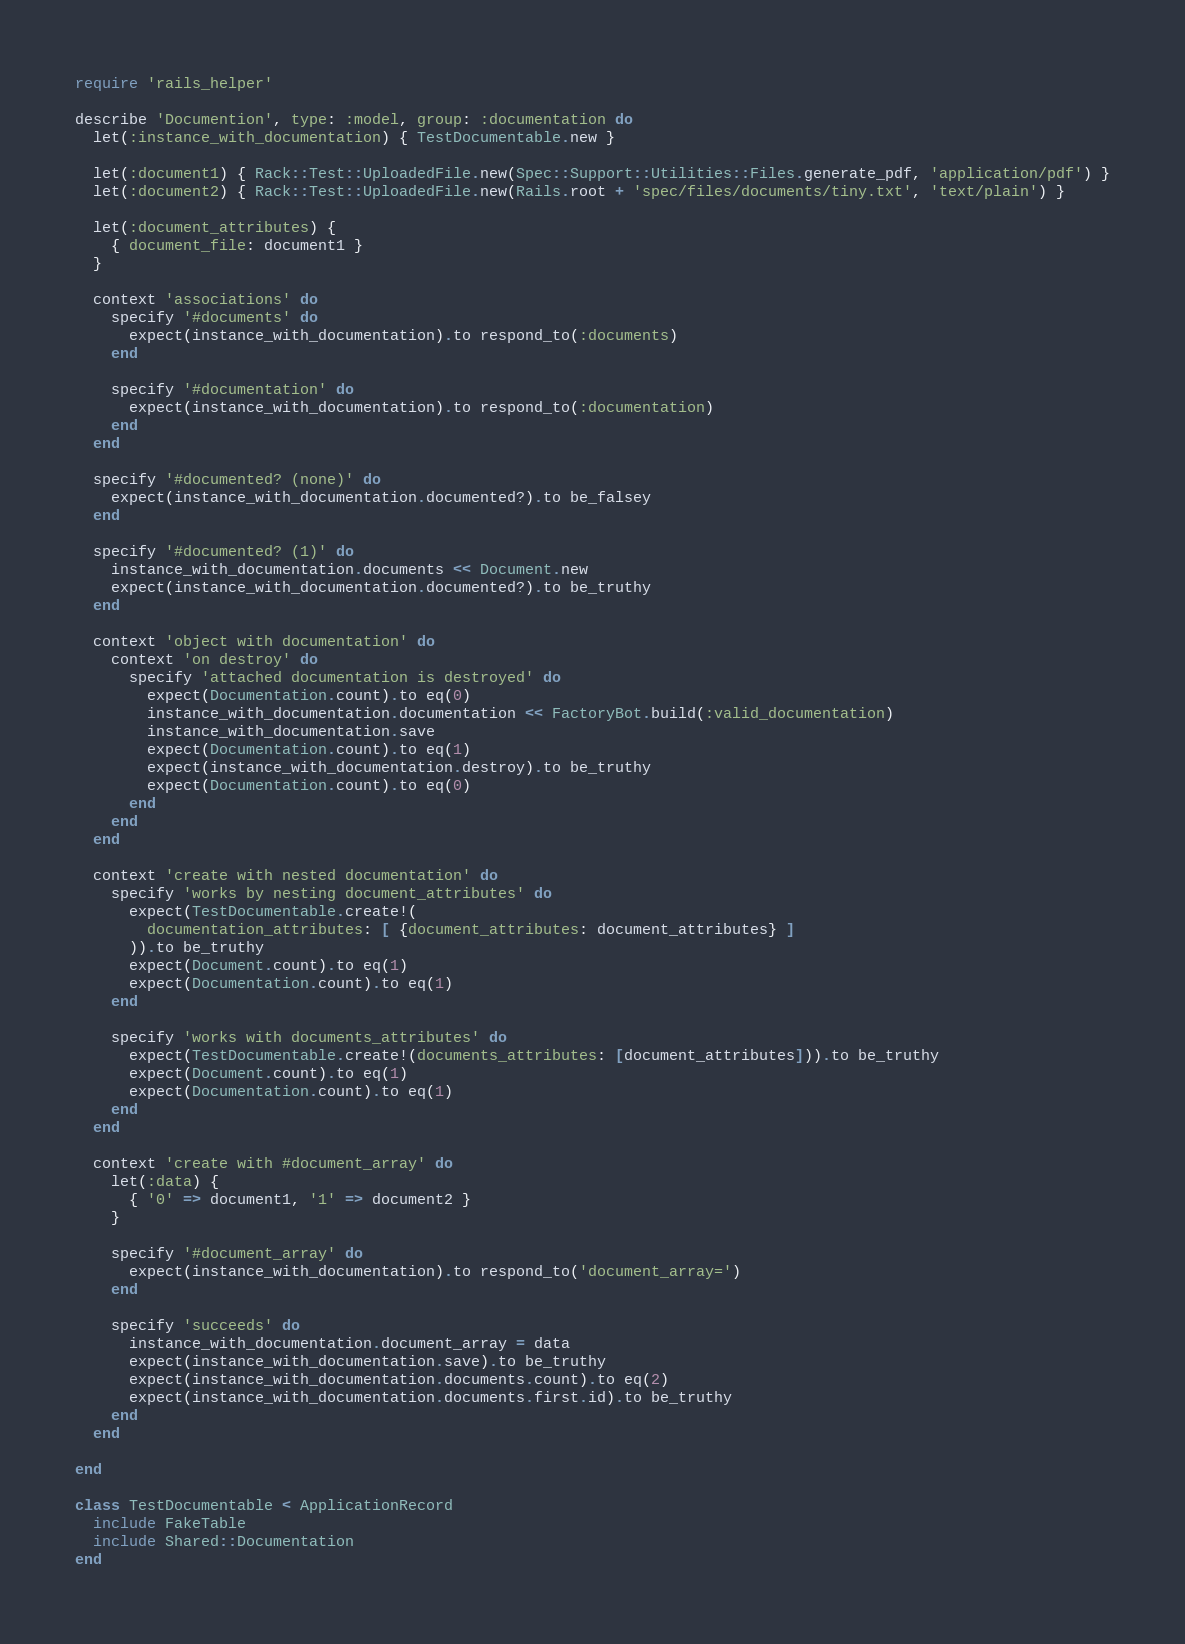<code> <loc_0><loc_0><loc_500><loc_500><_Ruby_>require 'rails_helper'

describe 'Documention', type: :model, group: :documentation do
  let(:instance_with_documentation) { TestDocumentable.new }

  let(:document1) { Rack::Test::UploadedFile.new(Spec::Support::Utilities::Files.generate_pdf, 'application/pdf') }
  let(:document2) { Rack::Test::UploadedFile.new(Rails.root + 'spec/files/documents/tiny.txt', 'text/plain') }

  let(:document_attributes) {
    { document_file: document1 }
  }

  context 'associations' do
    specify '#documents' do
      expect(instance_with_documentation).to respond_to(:documents)
    end

    specify '#documentation' do 
      expect(instance_with_documentation).to respond_to(:documentation)
    end
  end

  specify '#documented? (none)' do
    expect(instance_with_documentation.documented?).to be_falsey 
  end

  specify '#documented? (1)' do
    instance_with_documentation.documents << Document.new
    expect(instance_with_documentation.documented?).to be_truthy
  end

  context 'object with documentation' do
    context 'on destroy' do
      specify 'attached documentation is destroyed' do
        expect(Documentation.count).to eq(0)
        instance_with_documentation.documentation << FactoryBot.build(:valid_documentation)
        instance_with_documentation.save
        expect(Documentation.count).to eq(1)
        expect(instance_with_documentation.destroy).to be_truthy
        expect(Documentation.count).to eq(0)
      end
    end
  end

  context 'create with nested documentation' do
    specify 'works by nesting document_attributes' do
      expect(TestDocumentable.create!(
        documentation_attributes: [ {document_attributes: document_attributes} ]
      )).to be_truthy
      expect(Document.count).to eq(1)
      expect(Documentation.count).to eq(1)
    end

    specify 'works with documents_attributes' do
      expect(TestDocumentable.create!(documents_attributes: [document_attributes])).to be_truthy
      expect(Document.count).to eq(1)
      expect(Documentation.count).to eq(1)
    end
  end

  context 'create with #document_array' do
    let(:data) {
      { '0' => document1, '1' => document2 }
    }

    specify '#document_array' do
      expect(instance_with_documentation).to respond_to('document_array=')
    end

    specify 'succeeds' do
      instance_with_documentation.document_array = data
      expect(instance_with_documentation.save).to be_truthy
      expect(instance_with_documentation.documents.count).to eq(2)
      expect(instance_with_documentation.documents.first.id).to be_truthy
    end
  end

end

class TestDocumentable < ApplicationRecord
  include FakeTable
  include Shared::Documentation
end
</code> 